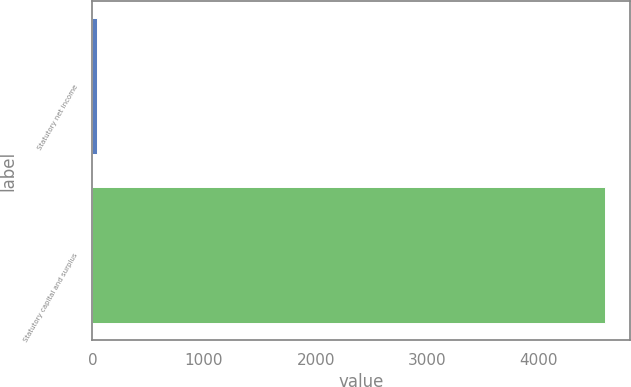Convert chart. <chart><loc_0><loc_0><loc_500><loc_500><bar_chart><fcel>Statutory net income<fcel>Statutory capital and surplus<nl><fcel>42.1<fcel>4588.7<nl></chart> 